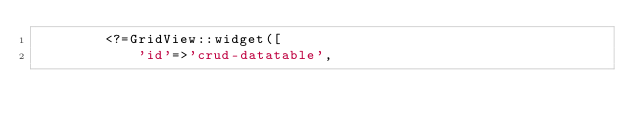<code> <loc_0><loc_0><loc_500><loc_500><_PHP_>        <?=GridView::widget([
            'id'=>'crud-datatable',</code> 